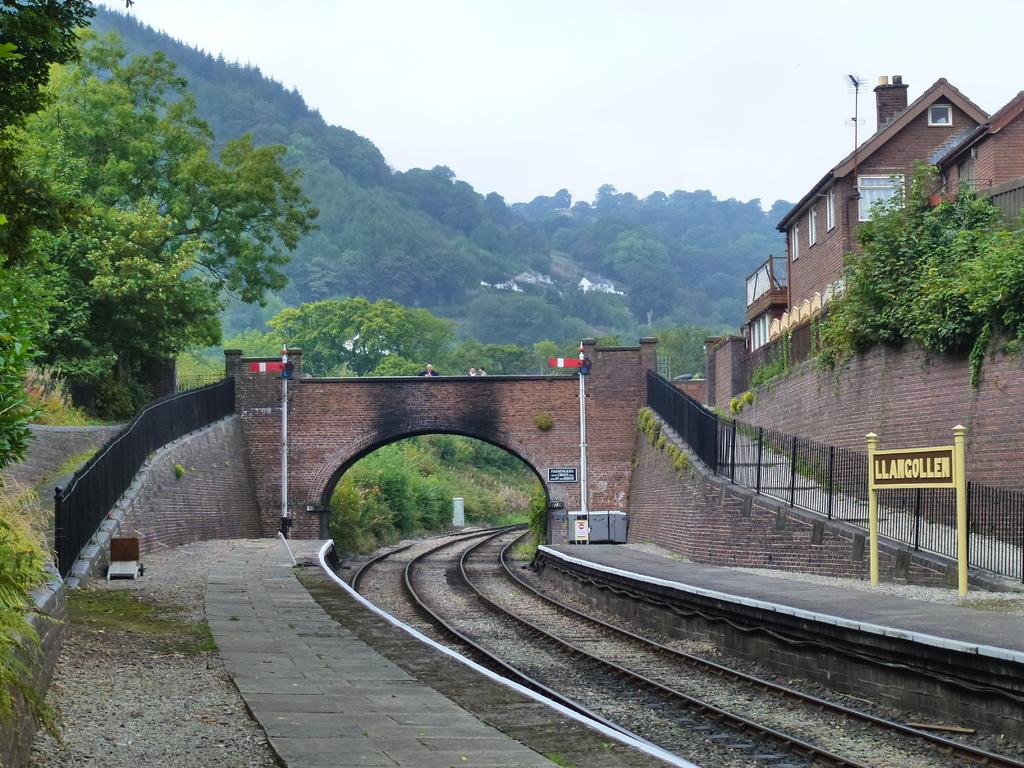Provide a one-sentence caption for the provided image. A railroad with a gate that says Llancollen. 